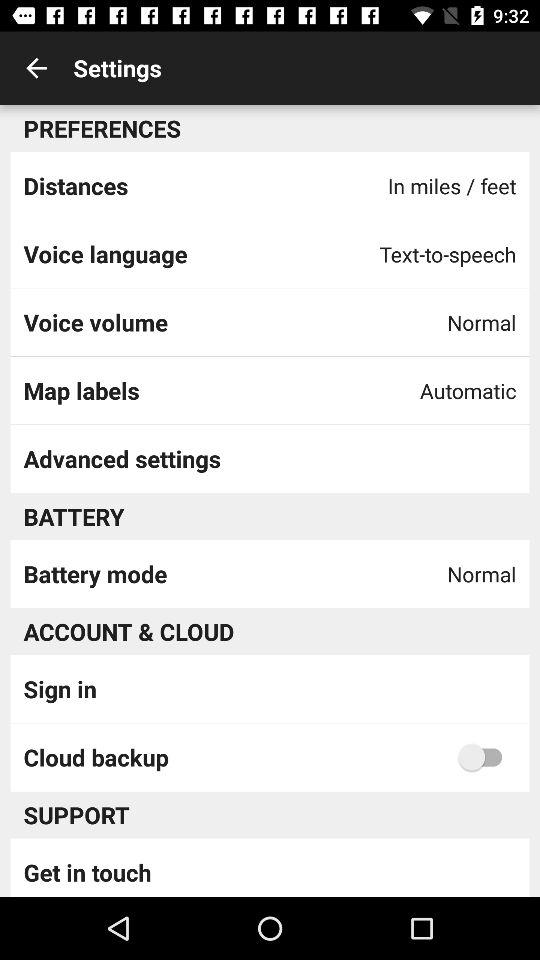What is the setting for cloud backup? The setting for cloud backup is "off". 